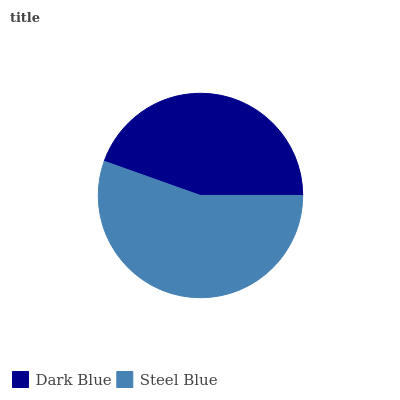Is Dark Blue the minimum?
Answer yes or no. Yes. Is Steel Blue the maximum?
Answer yes or no. Yes. Is Steel Blue the minimum?
Answer yes or no. No. Is Steel Blue greater than Dark Blue?
Answer yes or no. Yes. Is Dark Blue less than Steel Blue?
Answer yes or no. Yes. Is Dark Blue greater than Steel Blue?
Answer yes or no. No. Is Steel Blue less than Dark Blue?
Answer yes or no. No. Is Steel Blue the high median?
Answer yes or no. Yes. Is Dark Blue the low median?
Answer yes or no. Yes. Is Dark Blue the high median?
Answer yes or no. No. Is Steel Blue the low median?
Answer yes or no. No. 